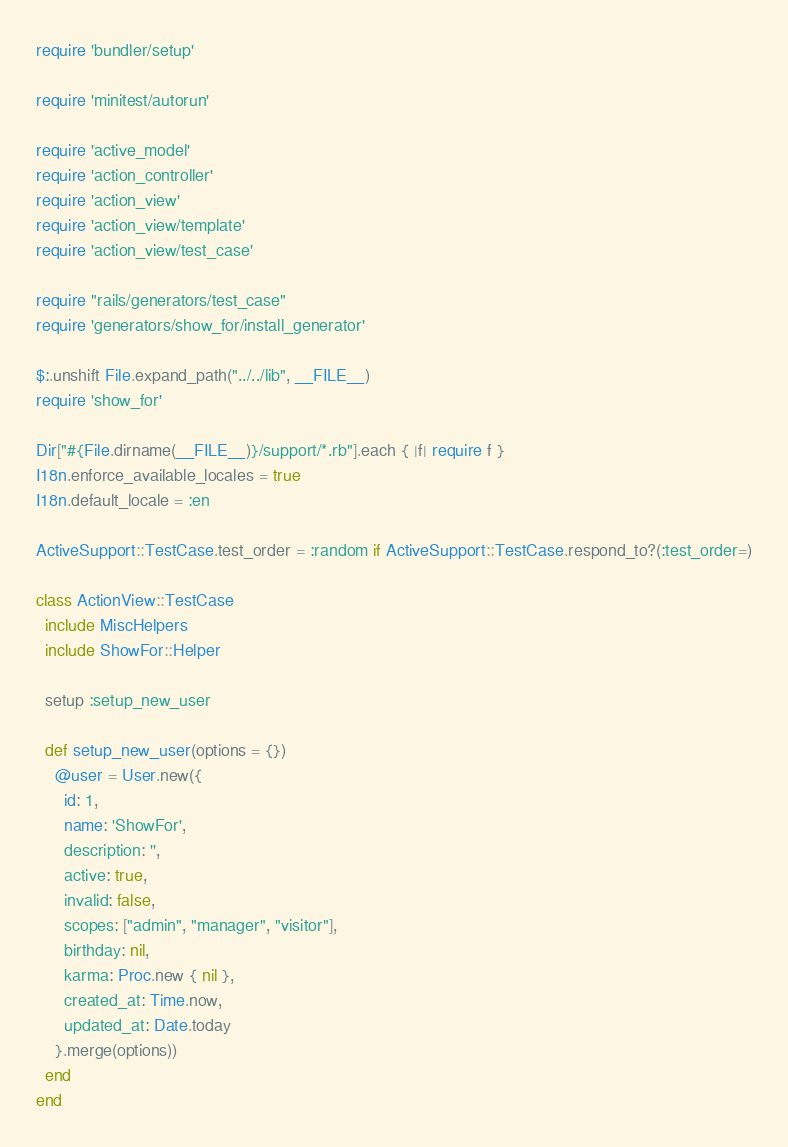<code> <loc_0><loc_0><loc_500><loc_500><_Ruby_>require 'bundler/setup'

require 'minitest/autorun'

require 'active_model'
require 'action_controller'
require 'action_view'
require 'action_view/template'
require 'action_view/test_case'

require "rails/generators/test_case"
require 'generators/show_for/install_generator'

$:.unshift File.expand_path("../../lib", __FILE__)
require 'show_for'

Dir["#{File.dirname(__FILE__)}/support/*.rb"].each { |f| require f }
I18n.enforce_available_locales = true
I18n.default_locale = :en

ActiveSupport::TestCase.test_order = :random if ActiveSupport::TestCase.respond_to?(:test_order=)

class ActionView::TestCase
  include MiscHelpers
  include ShowFor::Helper

  setup :setup_new_user

  def setup_new_user(options = {})
    @user = User.new({
      id: 1,
      name: 'ShowFor',
      description: '',
      active: true,
      invalid: false,
      scopes: ["admin", "manager", "visitor"],
      birthday: nil,
      karma: Proc.new { nil },
      created_at: Time.now,
      updated_at: Date.today
    }.merge(options))
  end
end
</code> 